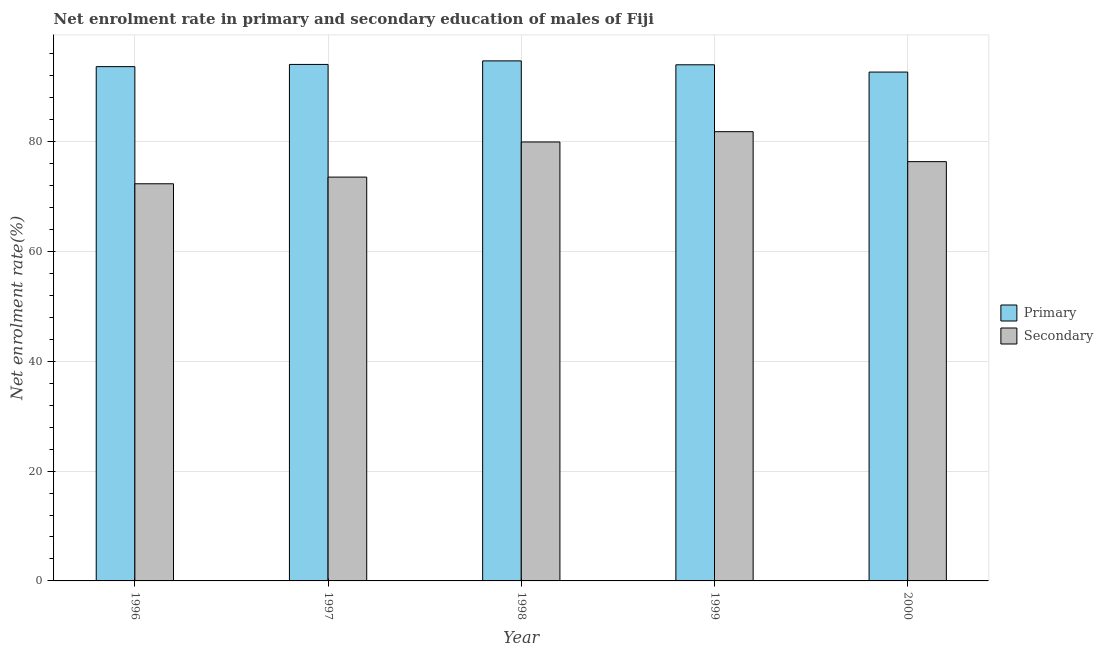How many different coloured bars are there?
Provide a succinct answer. 2. How many bars are there on the 2nd tick from the right?
Ensure brevity in your answer.  2. What is the enrollment rate in secondary education in 2000?
Your answer should be compact. 76.35. Across all years, what is the maximum enrollment rate in secondary education?
Offer a very short reply. 81.81. Across all years, what is the minimum enrollment rate in primary education?
Ensure brevity in your answer.  92.66. In which year was the enrollment rate in primary education maximum?
Keep it short and to the point. 1998. In which year was the enrollment rate in primary education minimum?
Provide a succinct answer. 2000. What is the total enrollment rate in primary education in the graph?
Ensure brevity in your answer.  469.06. What is the difference between the enrollment rate in secondary education in 1996 and that in 1998?
Offer a very short reply. -7.61. What is the difference between the enrollment rate in secondary education in 1998 and the enrollment rate in primary education in 2000?
Provide a succinct answer. 3.58. What is the average enrollment rate in secondary education per year?
Your answer should be compact. 76.79. In how many years, is the enrollment rate in primary education greater than 48 %?
Give a very brief answer. 5. What is the ratio of the enrollment rate in primary education in 1998 to that in 2000?
Your answer should be very brief. 1.02. Is the difference between the enrollment rate in primary education in 1999 and 2000 greater than the difference between the enrollment rate in secondary education in 1999 and 2000?
Offer a very short reply. No. What is the difference between the highest and the second highest enrollment rate in primary education?
Give a very brief answer. 0.65. What is the difference between the highest and the lowest enrollment rate in secondary education?
Make the answer very short. 9.49. In how many years, is the enrollment rate in secondary education greater than the average enrollment rate in secondary education taken over all years?
Make the answer very short. 2. Is the sum of the enrollment rate in secondary education in 1996 and 1998 greater than the maximum enrollment rate in primary education across all years?
Ensure brevity in your answer.  Yes. What does the 2nd bar from the left in 1999 represents?
Offer a very short reply. Secondary. What does the 2nd bar from the right in 1998 represents?
Make the answer very short. Primary. Are all the bars in the graph horizontal?
Make the answer very short. No. Does the graph contain any zero values?
Offer a very short reply. No. Does the graph contain grids?
Give a very brief answer. Yes. How are the legend labels stacked?
Your answer should be compact. Vertical. What is the title of the graph?
Give a very brief answer. Net enrolment rate in primary and secondary education of males of Fiji. What is the label or title of the X-axis?
Your answer should be compact. Year. What is the label or title of the Y-axis?
Provide a succinct answer. Net enrolment rate(%). What is the Net enrolment rate(%) in Primary in 1996?
Your answer should be compact. 93.65. What is the Net enrolment rate(%) of Secondary in 1996?
Ensure brevity in your answer.  72.32. What is the Net enrolment rate(%) of Primary in 1997?
Your answer should be compact. 94.05. What is the Net enrolment rate(%) of Secondary in 1997?
Provide a short and direct response. 73.54. What is the Net enrolment rate(%) of Primary in 1998?
Provide a succinct answer. 94.7. What is the Net enrolment rate(%) of Secondary in 1998?
Keep it short and to the point. 79.93. What is the Net enrolment rate(%) of Primary in 1999?
Give a very brief answer. 93.99. What is the Net enrolment rate(%) of Secondary in 1999?
Offer a terse response. 81.81. What is the Net enrolment rate(%) in Primary in 2000?
Your response must be concise. 92.66. What is the Net enrolment rate(%) of Secondary in 2000?
Provide a succinct answer. 76.35. Across all years, what is the maximum Net enrolment rate(%) in Primary?
Your answer should be compact. 94.7. Across all years, what is the maximum Net enrolment rate(%) in Secondary?
Offer a terse response. 81.81. Across all years, what is the minimum Net enrolment rate(%) in Primary?
Offer a terse response. 92.66. Across all years, what is the minimum Net enrolment rate(%) in Secondary?
Offer a terse response. 72.32. What is the total Net enrolment rate(%) of Primary in the graph?
Keep it short and to the point. 469.06. What is the total Net enrolment rate(%) in Secondary in the graph?
Provide a succinct answer. 383.95. What is the difference between the Net enrolment rate(%) of Primary in 1996 and that in 1997?
Offer a very short reply. -0.4. What is the difference between the Net enrolment rate(%) in Secondary in 1996 and that in 1997?
Provide a succinct answer. -1.21. What is the difference between the Net enrolment rate(%) in Primary in 1996 and that in 1998?
Provide a short and direct response. -1.05. What is the difference between the Net enrolment rate(%) of Secondary in 1996 and that in 1998?
Your answer should be very brief. -7.61. What is the difference between the Net enrolment rate(%) in Primary in 1996 and that in 1999?
Ensure brevity in your answer.  -0.34. What is the difference between the Net enrolment rate(%) in Secondary in 1996 and that in 1999?
Your answer should be very brief. -9.49. What is the difference between the Net enrolment rate(%) in Primary in 1996 and that in 2000?
Offer a terse response. 0.99. What is the difference between the Net enrolment rate(%) in Secondary in 1996 and that in 2000?
Provide a succinct answer. -4.03. What is the difference between the Net enrolment rate(%) in Primary in 1997 and that in 1998?
Make the answer very short. -0.65. What is the difference between the Net enrolment rate(%) of Secondary in 1997 and that in 1998?
Your response must be concise. -6.4. What is the difference between the Net enrolment rate(%) in Primary in 1997 and that in 1999?
Your response must be concise. 0.07. What is the difference between the Net enrolment rate(%) in Secondary in 1997 and that in 1999?
Provide a short and direct response. -8.27. What is the difference between the Net enrolment rate(%) in Primary in 1997 and that in 2000?
Offer a terse response. 1.39. What is the difference between the Net enrolment rate(%) in Secondary in 1997 and that in 2000?
Your answer should be compact. -2.82. What is the difference between the Net enrolment rate(%) of Primary in 1998 and that in 1999?
Make the answer very short. 0.71. What is the difference between the Net enrolment rate(%) of Secondary in 1998 and that in 1999?
Offer a terse response. -1.87. What is the difference between the Net enrolment rate(%) in Primary in 1998 and that in 2000?
Provide a succinct answer. 2.04. What is the difference between the Net enrolment rate(%) in Secondary in 1998 and that in 2000?
Make the answer very short. 3.58. What is the difference between the Net enrolment rate(%) of Primary in 1999 and that in 2000?
Your answer should be compact. 1.33. What is the difference between the Net enrolment rate(%) of Secondary in 1999 and that in 2000?
Give a very brief answer. 5.46. What is the difference between the Net enrolment rate(%) in Primary in 1996 and the Net enrolment rate(%) in Secondary in 1997?
Keep it short and to the point. 20.12. What is the difference between the Net enrolment rate(%) in Primary in 1996 and the Net enrolment rate(%) in Secondary in 1998?
Ensure brevity in your answer.  13.72. What is the difference between the Net enrolment rate(%) in Primary in 1996 and the Net enrolment rate(%) in Secondary in 1999?
Make the answer very short. 11.85. What is the difference between the Net enrolment rate(%) in Primary in 1996 and the Net enrolment rate(%) in Secondary in 2000?
Make the answer very short. 17.3. What is the difference between the Net enrolment rate(%) in Primary in 1997 and the Net enrolment rate(%) in Secondary in 1998?
Provide a short and direct response. 14.12. What is the difference between the Net enrolment rate(%) of Primary in 1997 and the Net enrolment rate(%) of Secondary in 1999?
Give a very brief answer. 12.25. What is the difference between the Net enrolment rate(%) in Primary in 1997 and the Net enrolment rate(%) in Secondary in 2000?
Offer a terse response. 17.7. What is the difference between the Net enrolment rate(%) in Primary in 1998 and the Net enrolment rate(%) in Secondary in 1999?
Your answer should be very brief. 12.89. What is the difference between the Net enrolment rate(%) of Primary in 1998 and the Net enrolment rate(%) of Secondary in 2000?
Provide a succinct answer. 18.35. What is the difference between the Net enrolment rate(%) of Primary in 1999 and the Net enrolment rate(%) of Secondary in 2000?
Your response must be concise. 17.64. What is the average Net enrolment rate(%) of Primary per year?
Ensure brevity in your answer.  93.81. What is the average Net enrolment rate(%) in Secondary per year?
Offer a very short reply. 76.79. In the year 1996, what is the difference between the Net enrolment rate(%) in Primary and Net enrolment rate(%) in Secondary?
Give a very brief answer. 21.33. In the year 1997, what is the difference between the Net enrolment rate(%) in Primary and Net enrolment rate(%) in Secondary?
Provide a short and direct response. 20.52. In the year 1998, what is the difference between the Net enrolment rate(%) of Primary and Net enrolment rate(%) of Secondary?
Provide a short and direct response. 14.77. In the year 1999, what is the difference between the Net enrolment rate(%) of Primary and Net enrolment rate(%) of Secondary?
Your answer should be compact. 12.18. In the year 2000, what is the difference between the Net enrolment rate(%) of Primary and Net enrolment rate(%) of Secondary?
Your response must be concise. 16.31. What is the ratio of the Net enrolment rate(%) of Primary in 1996 to that in 1997?
Give a very brief answer. 1. What is the ratio of the Net enrolment rate(%) in Secondary in 1996 to that in 1997?
Your answer should be very brief. 0.98. What is the ratio of the Net enrolment rate(%) in Primary in 1996 to that in 1998?
Your answer should be very brief. 0.99. What is the ratio of the Net enrolment rate(%) in Secondary in 1996 to that in 1998?
Offer a terse response. 0.9. What is the ratio of the Net enrolment rate(%) of Secondary in 1996 to that in 1999?
Provide a short and direct response. 0.88. What is the ratio of the Net enrolment rate(%) in Primary in 1996 to that in 2000?
Ensure brevity in your answer.  1.01. What is the ratio of the Net enrolment rate(%) in Secondary in 1996 to that in 2000?
Your response must be concise. 0.95. What is the ratio of the Net enrolment rate(%) of Secondary in 1997 to that in 1998?
Ensure brevity in your answer.  0.92. What is the ratio of the Net enrolment rate(%) in Primary in 1997 to that in 1999?
Your response must be concise. 1. What is the ratio of the Net enrolment rate(%) in Secondary in 1997 to that in 1999?
Your response must be concise. 0.9. What is the ratio of the Net enrolment rate(%) in Secondary in 1997 to that in 2000?
Provide a succinct answer. 0.96. What is the ratio of the Net enrolment rate(%) in Primary in 1998 to that in 1999?
Offer a terse response. 1.01. What is the ratio of the Net enrolment rate(%) in Secondary in 1998 to that in 1999?
Your answer should be compact. 0.98. What is the ratio of the Net enrolment rate(%) of Secondary in 1998 to that in 2000?
Give a very brief answer. 1.05. What is the ratio of the Net enrolment rate(%) of Primary in 1999 to that in 2000?
Your response must be concise. 1.01. What is the ratio of the Net enrolment rate(%) of Secondary in 1999 to that in 2000?
Provide a short and direct response. 1.07. What is the difference between the highest and the second highest Net enrolment rate(%) of Primary?
Your answer should be very brief. 0.65. What is the difference between the highest and the second highest Net enrolment rate(%) of Secondary?
Offer a terse response. 1.87. What is the difference between the highest and the lowest Net enrolment rate(%) of Primary?
Offer a very short reply. 2.04. What is the difference between the highest and the lowest Net enrolment rate(%) in Secondary?
Your response must be concise. 9.49. 